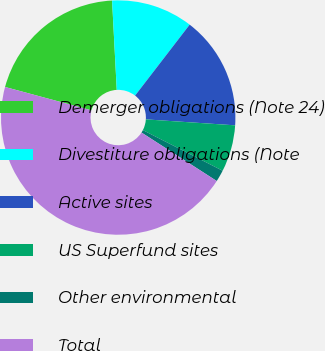Convert chart. <chart><loc_0><loc_0><loc_500><loc_500><pie_chart><fcel>Demerger obligations (Note 24)<fcel>Divestiture obligations (Note<fcel>Active sites<fcel>US Superfund sites<fcel>Other environmental<fcel>Total<nl><fcel>19.97%<fcel>11.27%<fcel>15.62%<fcel>6.44%<fcel>1.61%<fcel>45.09%<nl></chart> 